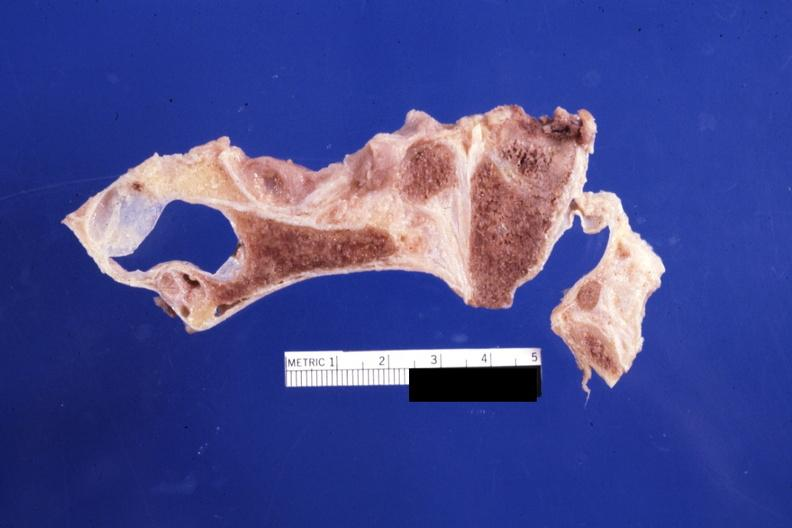s fetus developing very early present?
Answer the question using a single word or phrase. No 